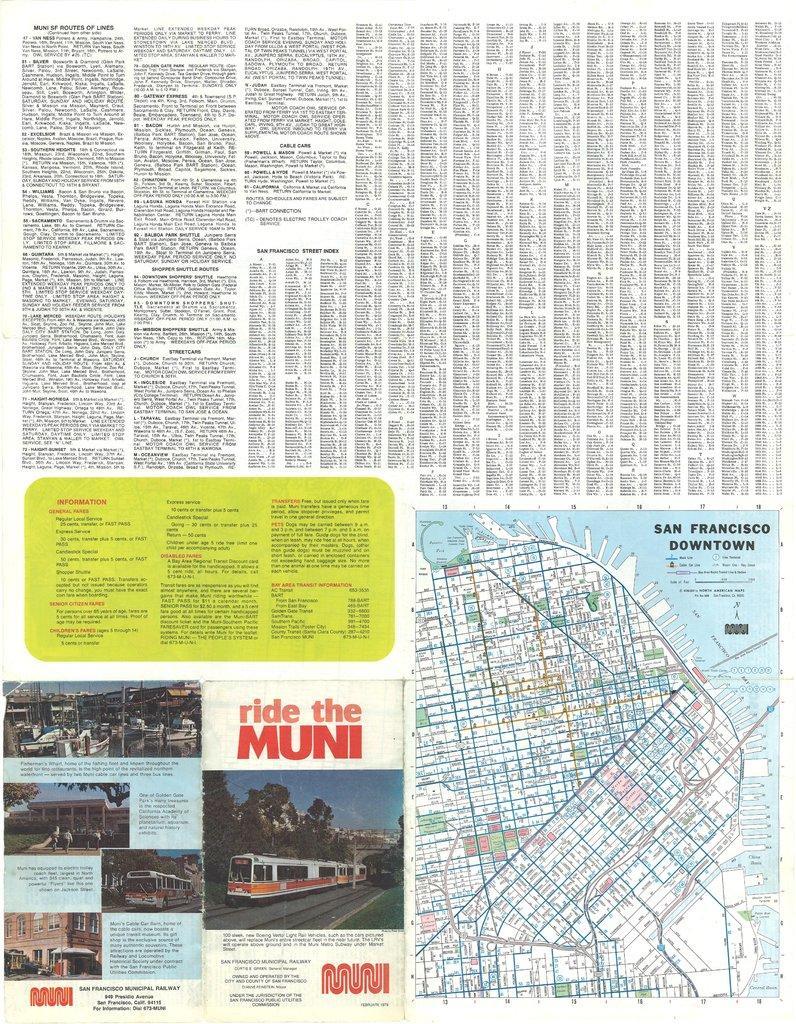Can you describe this image briefly? The picture looks like a newspaper column. In the picture we can see text, map, bus, people and various objects. 